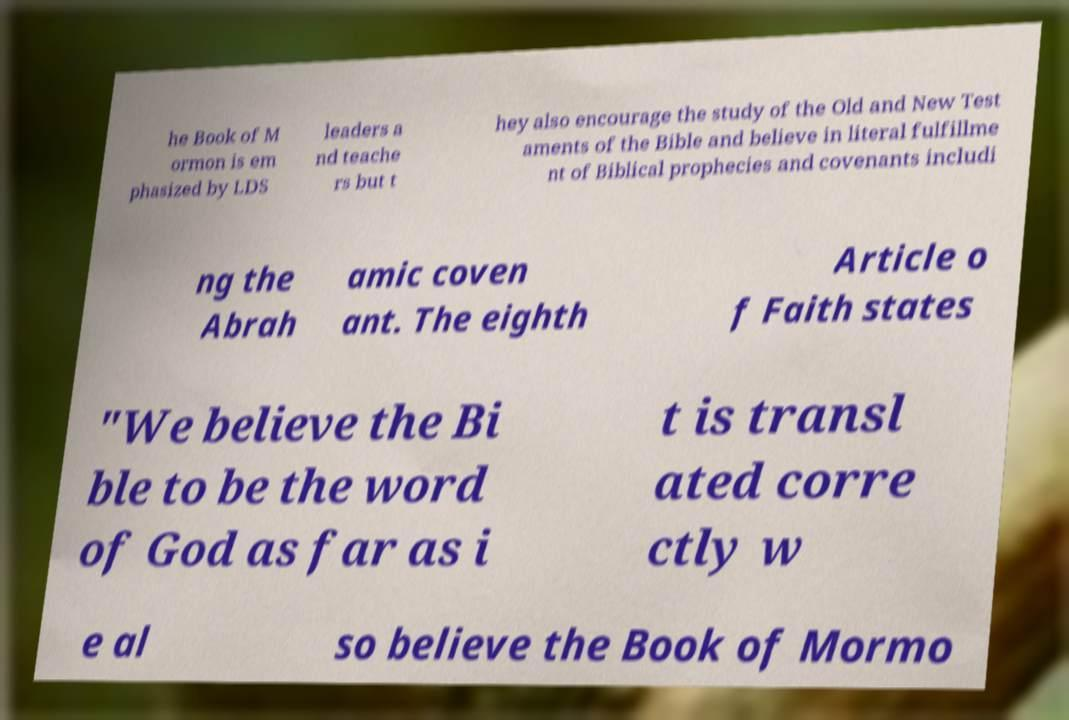Could you extract and type out the text from this image? he Book of M ormon is em phasized by LDS leaders a nd teache rs but t hey also encourage the study of the Old and New Test aments of the Bible and believe in literal fulfillme nt of Biblical prophecies and covenants includi ng the Abrah amic coven ant. The eighth Article o f Faith states "We believe the Bi ble to be the word of God as far as i t is transl ated corre ctly w e al so believe the Book of Mormo 